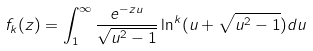<formula> <loc_0><loc_0><loc_500><loc_500>f _ { k } ( z ) = \int _ { 1 } ^ { \infty } \frac { e ^ { - z u } } { \sqrt { u ^ { 2 } - 1 } } \ln ^ { k } ( u + \sqrt { u ^ { 2 } - 1 } ) d u</formula> 